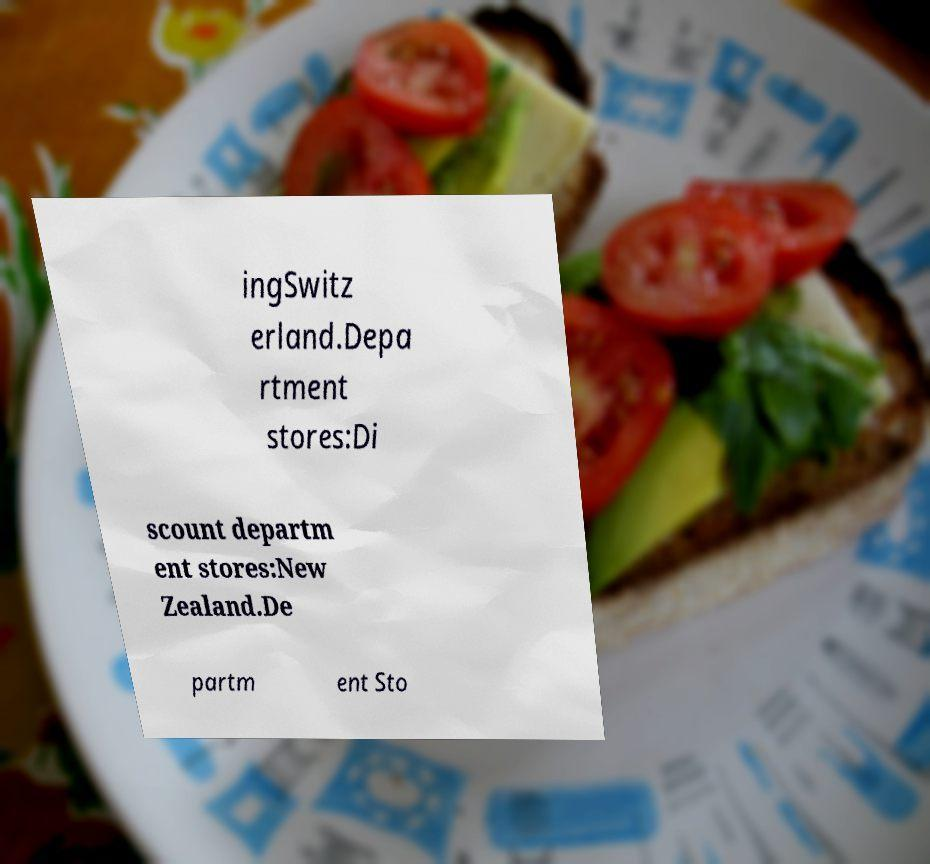Can you accurately transcribe the text from the provided image for me? ingSwitz erland.Depa rtment stores:Di scount departm ent stores:New Zealand.De partm ent Sto 